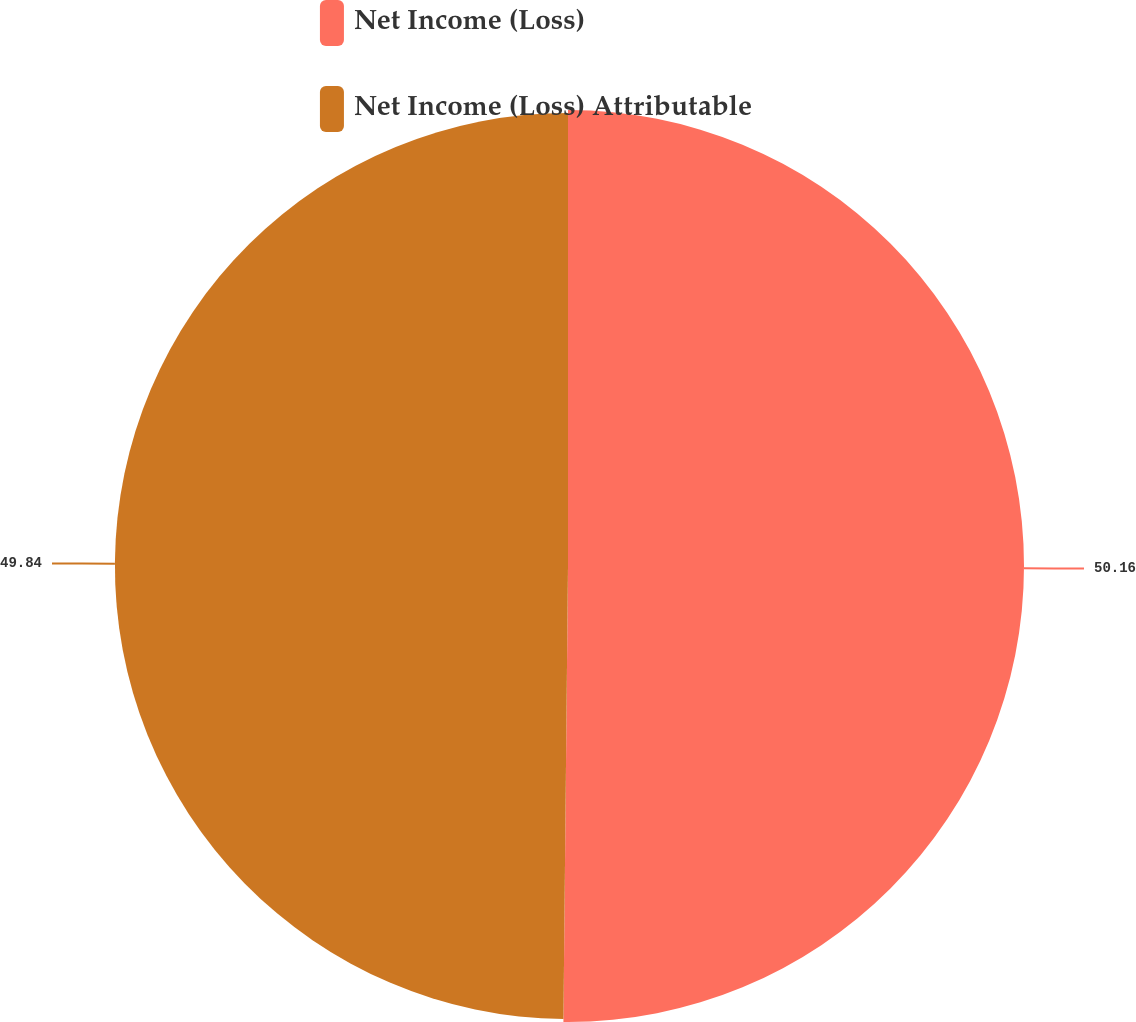Convert chart. <chart><loc_0><loc_0><loc_500><loc_500><pie_chart><fcel>Net Income (Loss)<fcel>Net Income (Loss) Attributable<nl><fcel>50.16%<fcel>49.84%<nl></chart> 